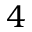Convert formula to latex. <formula><loc_0><loc_0><loc_500><loc_500>4</formula> 